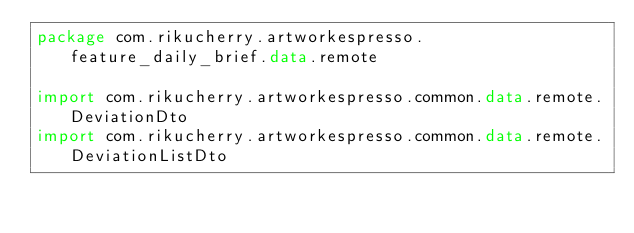<code> <loc_0><loc_0><loc_500><loc_500><_Kotlin_>package com.rikucherry.artworkespresso.feature_daily_brief.data.remote

import com.rikucherry.artworkespresso.common.data.remote.DeviationDto
import com.rikucherry.artworkespresso.common.data.remote.DeviationListDto</code> 